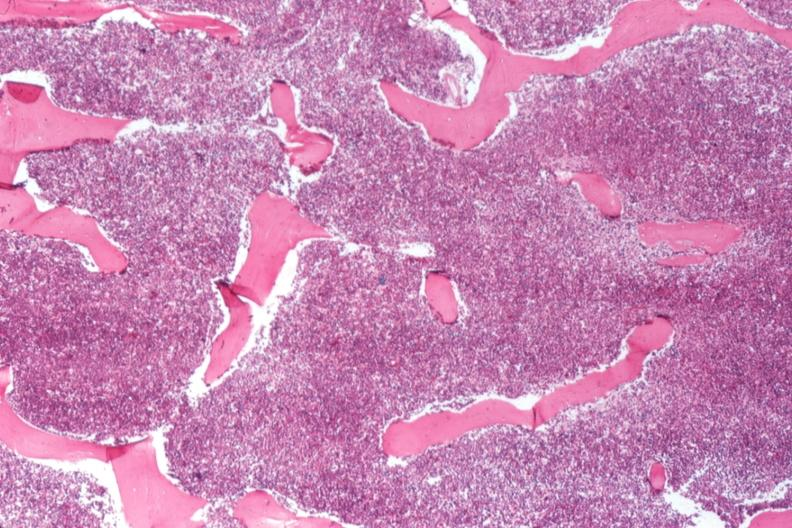does metastatic pancreas carcinoma show 100 % cellular marrow?
Answer the question using a single word or phrase. No 